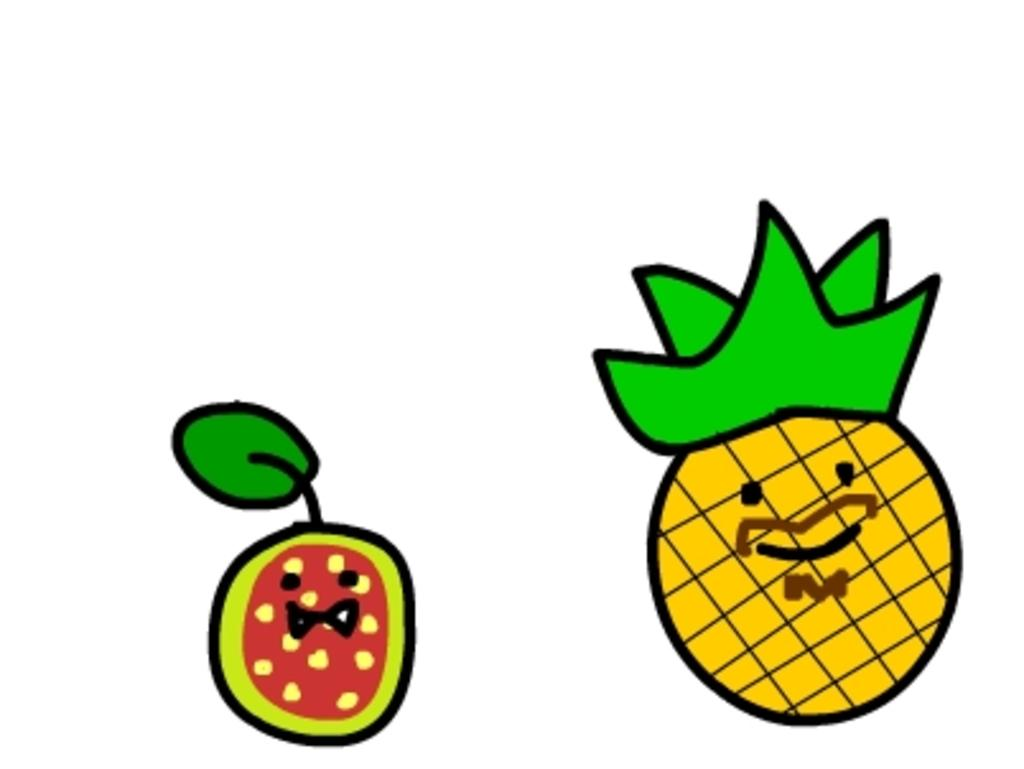What is the main subject of the image? There is a painting in the image. What is depicted in the painting? The painting depicts two fruits. Do the fruits have any additional features? Yes, the fruits have leaves. What color is the background of the painting? The background of the painting is white. What is the interest rate of the loan mentioned in the painting? There is no mention of a loan or interest rate in the painting; it depicts two fruits with leaves and a white background. 